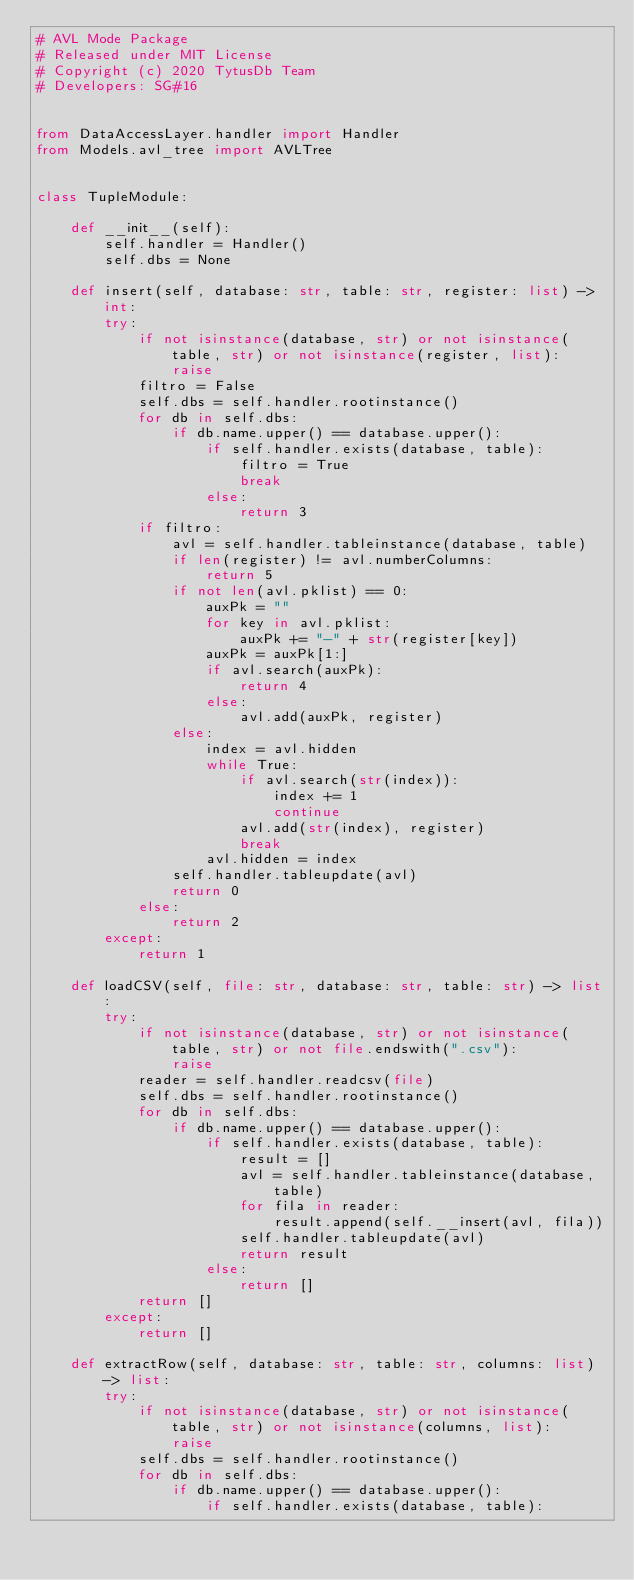<code> <loc_0><loc_0><loc_500><loc_500><_Python_># AVL Mode Package
# Released under MIT License
# Copyright (c) 2020 TytusDb Team
# Developers: SG#16


from DataAccessLayer.handler import Handler
from Models.avl_tree import AVLTree


class TupleModule:

    def __init__(self):
        self.handler = Handler()
        self.dbs = None

    def insert(self, database: str, table: str, register: list) -> int:
        try:
            if not isinstance(database, str) or not isinstance(table, str) or not isinstance(register, list):
                raise
            filtro = False
            self.dbs = self.handler.rootinstance()
            for db in self.dbs:
                if db.name.upper() == database.upper():
                    if self.handler.exists(database, table):
                        filtro = True
                        break
                    else:
                        return 3
            if filtro:
                avl = self.handler.tableinstance(database, table)
                if len(register) != avl.numberColumns:
                    return 5
                if not len(avl.pklist) == 0:
                    auxPk = ""
                    for key in avl.pklist:
                        auxPk += "-" + str(register[key])
                    auxPk = auxPk[1:]
                    if avl.search(auxPk):
                        return 4
                    else:
                        avl.add(auxPk, register)
                else:
                    index = avl.hidden
                    while True:
                        if avl.search(str(index)):
                            index += 1
                            continue
                        avl.add(str(index), register)
                        break
                    avl.hidden = index
                self.handler.tableupdate(avl)
                return 0
            else:
                return 2
        except:
            return 1

    def loadCSV(self, file: str, database: str, table: str) -> list:
        try:
            if not isinstance(database, str) or not isinstance(table, str) or not file.endswith(".csv"):
                raise
            reader = self.handler.readcsv(file)
            self.dbs = self.handler.rootinstance()
            for db in self.dbs:
                if db.name.upper() == database.upper():
                    if self.handler.exists(database, table):
                        result = []
                        avl = self.handler.tableinstance(database, table)
                        for fila in reader:
                            result.append(self.__insert(avl, fila))
                        self.handler.tableupdate(avl)
                        return result
                    else:
                        return []
            return []
        except:
            return []

    def extractRow(self, database: str, table: str, columns: list) -> list:
        try:
            if not isinstance(database, str) or not isinstance(table, str) or not isinstance(columns, list):
                raise
            self.dbs = self.handler.rootinstance()
            for db in self.dbs:
                if db.name.upper() == database.upper():
                    if self.handler.exists(database, table):</code> 